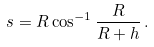<formula> <loc_0><loc_0><loc_500><loc_500>s = R \cos ^ { - 1 } { \frac { R } { R + h } } \, .</formula> 